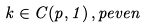<formula> <loc_0><loc_0><loc_500><loc_500>k \in C ( p , 1 ) \, , p e v e n</formula> 